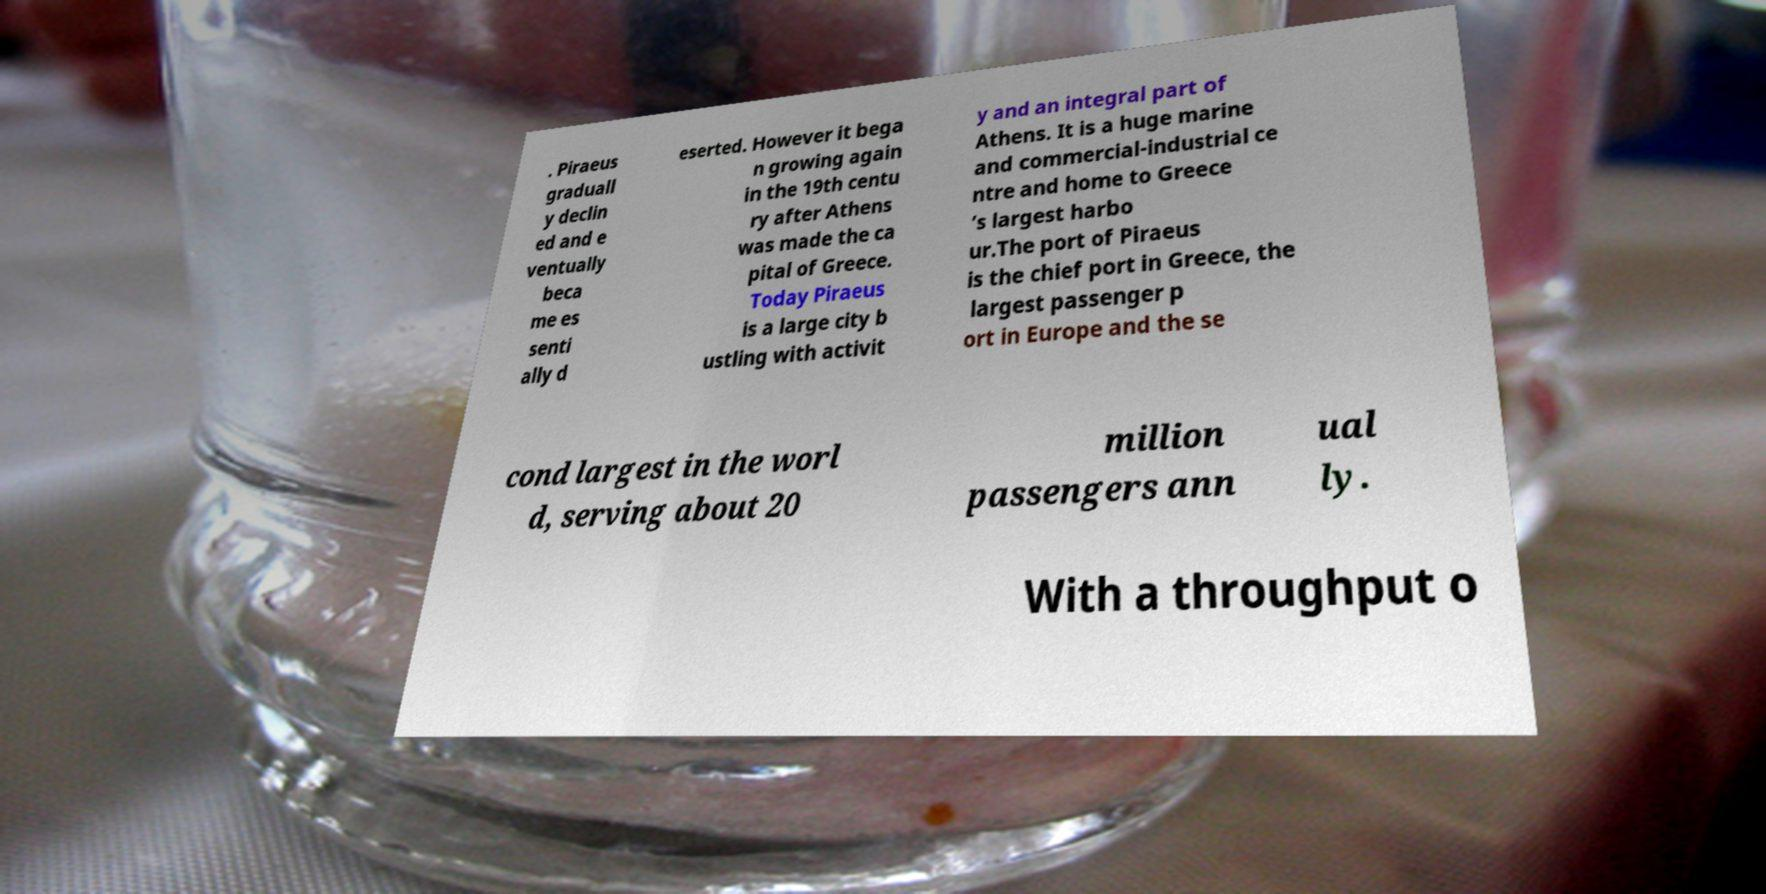Could you extract and type out the text from this image? . Piraeus graduall y declin ed and e ventually beca me es senti ally d eserted. However it bega n growing again in the 19th centu ry after Athens was made the ca pital of Greece. Today Piraeus is a large city b ustling with activit y and an integral part of Athens. It is a huge marine and commercial-industrial ce ntre and home to Greece ’s largest harbo ur.The port of Piraeus is the chief port in Greece, the largest passenger p ort in Europe and the se cond largest in the worl d, serving about 20 million passengers ann ual ly. With a throughput o 